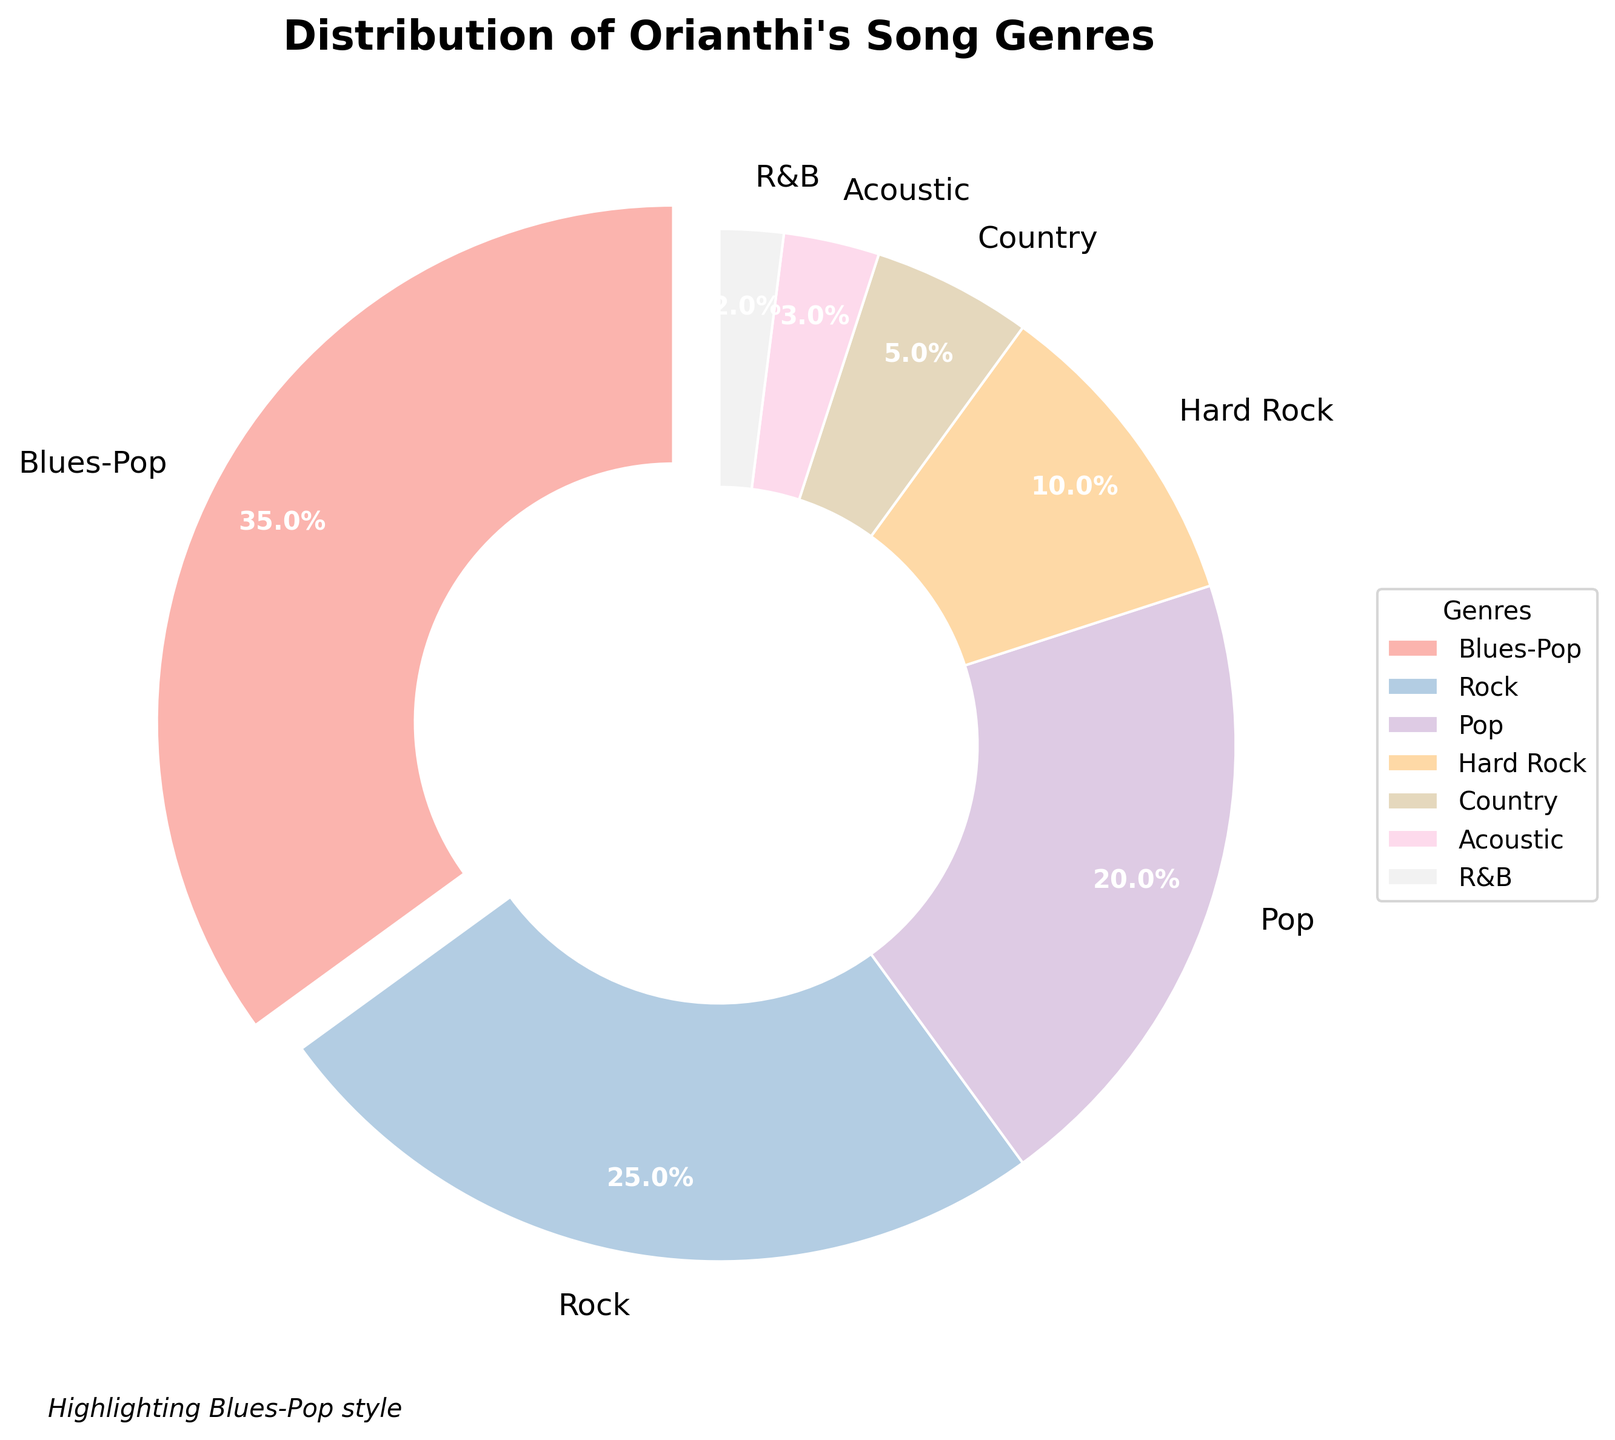Which genre has the highest percentage of Orianthi's songs? The pie chart shows the percentage of each genre. The largest slice, which is highlighted, represents the Blues-Pop genre.
Answer: Blues-Pop How much more percentage does Blues-Pop have compared to Rock? Blues-Pop has 35% and Rock has 25%. To find the difference, subtract Rock's percentage from Blues-Pop's percentage (35% - 25%).
Answer: 10% What is the total percentage of genres that are not Blues-Pop and Rock? Sum the percentages of the genres except Blues-Pop and Rock: Pop (20%) + Hard Rock (10%) + Country (5%) + Acoustic (3%) + R&B (2%). The total is 20% + 10% + 5% + 3% + 2%.
Answer: 40% Which genre has the smallest percentage and what is that percentage? The smallest slice in the pie chart corresponds to the genre with the smallest percentage, which is R&B with 2%.
Answer: R&B, 2% What is the combined percentage of Hard Rock, Country, and Acoustic? Add the percentages of Hard Rock (10%), Country (5%), and Acoustic (3%): 10% + 5% + 3% = 18%.
Answer: 18% How does the percentage of Pop songs compare to the percentage of Rock songs? The pie chart shows that Pop songs have 20% while Rock songs have 25%. Pop has 5% less than Rock.
Answer: Pop has 5% less than Rock Which genres together make up more than half of Orianthi's songs? Add the percentages of the top genres until the total exceeds 50%. Blues-Pop (35%) + Rock (25%) = 60%, which is more than half.
Answer: Blues-Pop and Rock What percentage of Orianthi's songs falls under genres classified under 10%? Add the percentages of genres that have less than 10%: Country (5%), Acoustic (3%), and R&B (2%): 5% + 3% + 2% = 10%.
Answer: 10% How much percentage more does Hard Rock have than Acoustic? Hard Rock is 10% and Acoustic is 3%. Subtract Acoustic's percentage from Hard Rock's percentage (10% - 3%).
Answer: 7% What is the most visually prominent feature of the pie chart? The most visually prominent feature is the slice representing Blues-Pop, which is highlighted by being slightly apart from the rest.
Answer: Highlighted Blues-Pop slice 